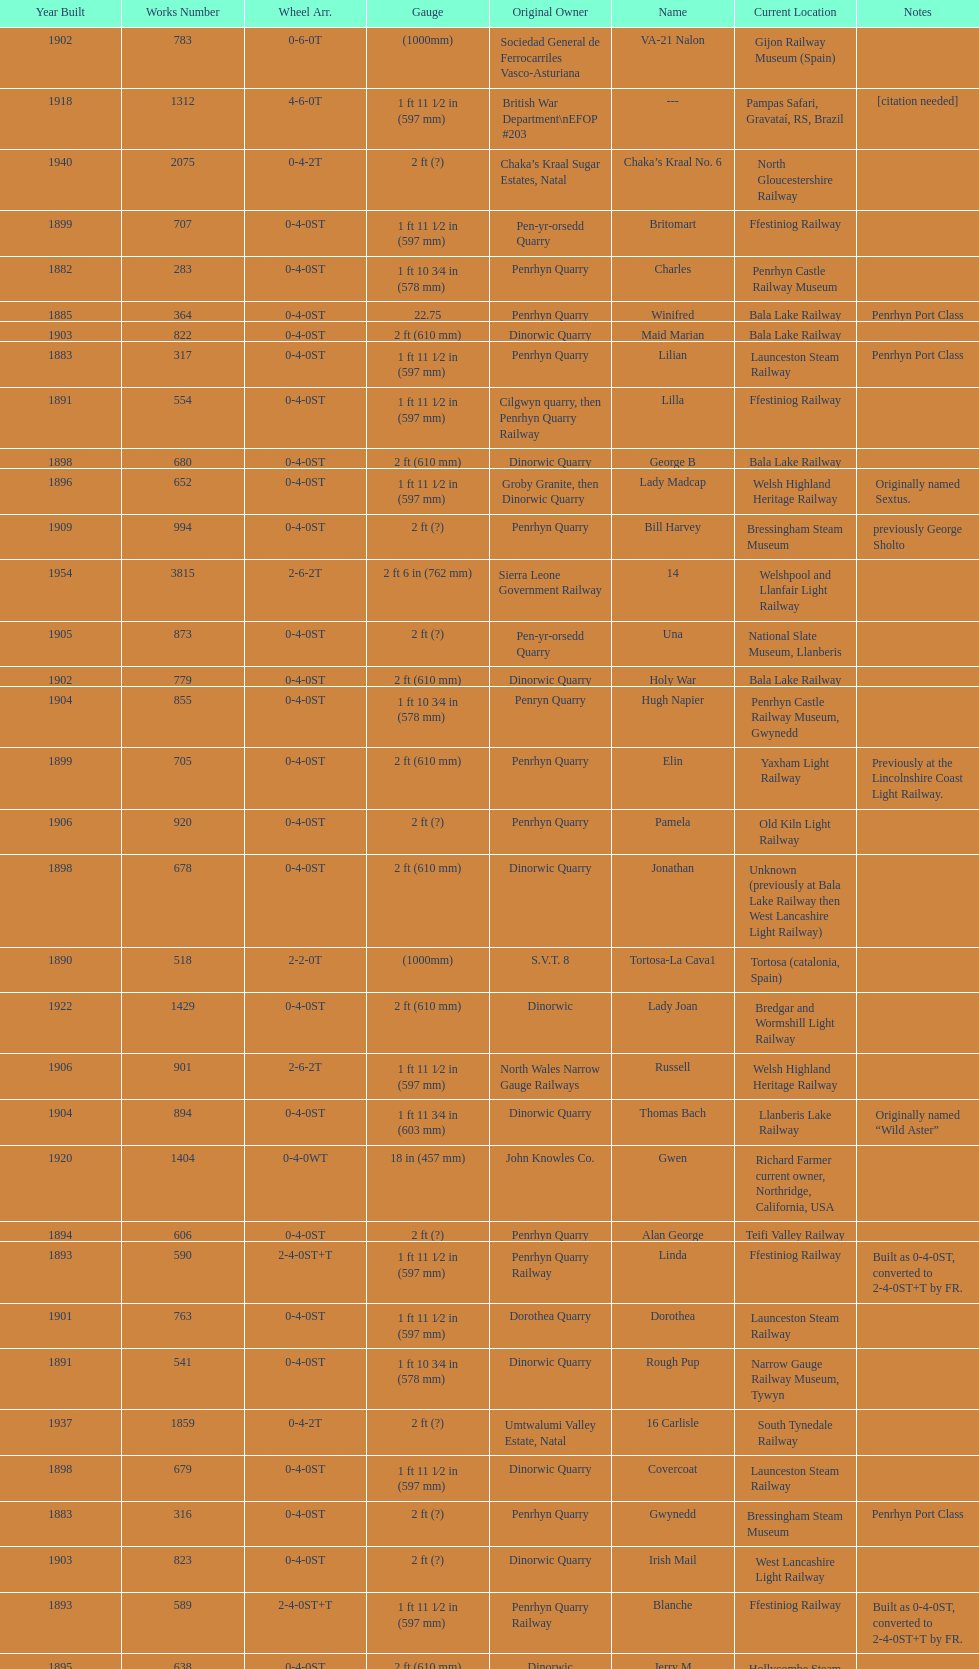What is the variation in gauge between works numbers 541 and 542? 32 mm. 